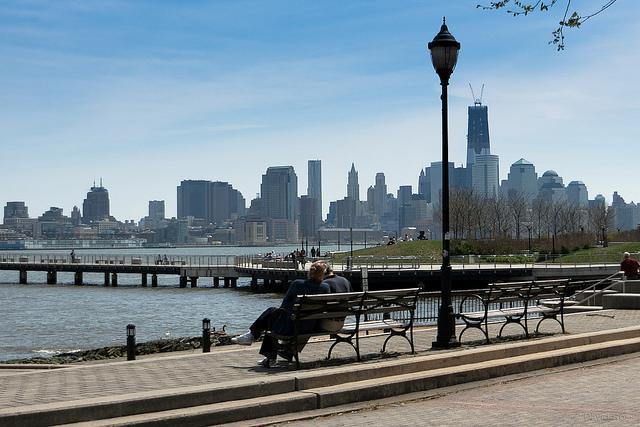Who is this area designed for?
Choose the correct response and explain in the format: 'Answer: answer
Rationale: rationale.'
Options: Employees, public, customers, politicians. Answer: public.
Rationale: There is a walkway and lots of benches 